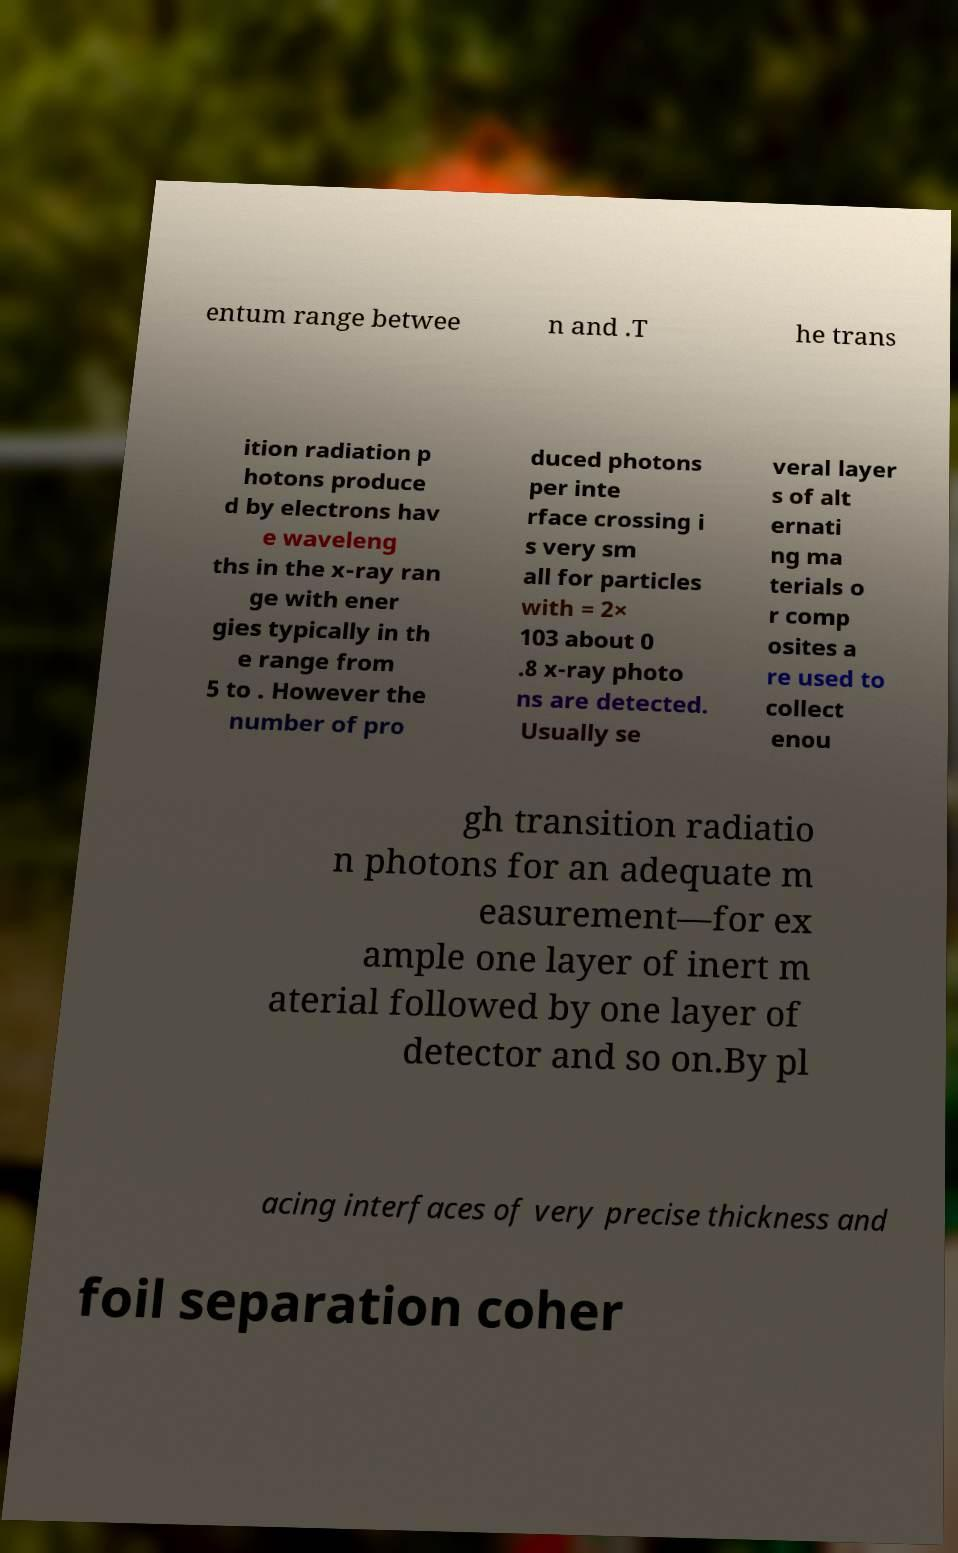Could you assist in decoding the text presented in this image and type it out clearly? entum range betwee n and .T he trans ition radiation p hotons produce d by electrons hav e waveleng ths in the x-ray ran ge with ener gies typically in th e range from 5 to . However the number of pro duced photons per inte rface crossing i s very sm all for particles with = 2× 103 about 0 .8 x-ray photo ns are detected. Usually se veral layer s of alt ernati ng ma terials o r comp osites a re used to collect enou gh transition radiatio n photons for an adequate m easurement—for ex ample one layer of inert m aterial followed by one layer of detector and so on.By pl acing interfaces of very precise thickness and foil separation coher 